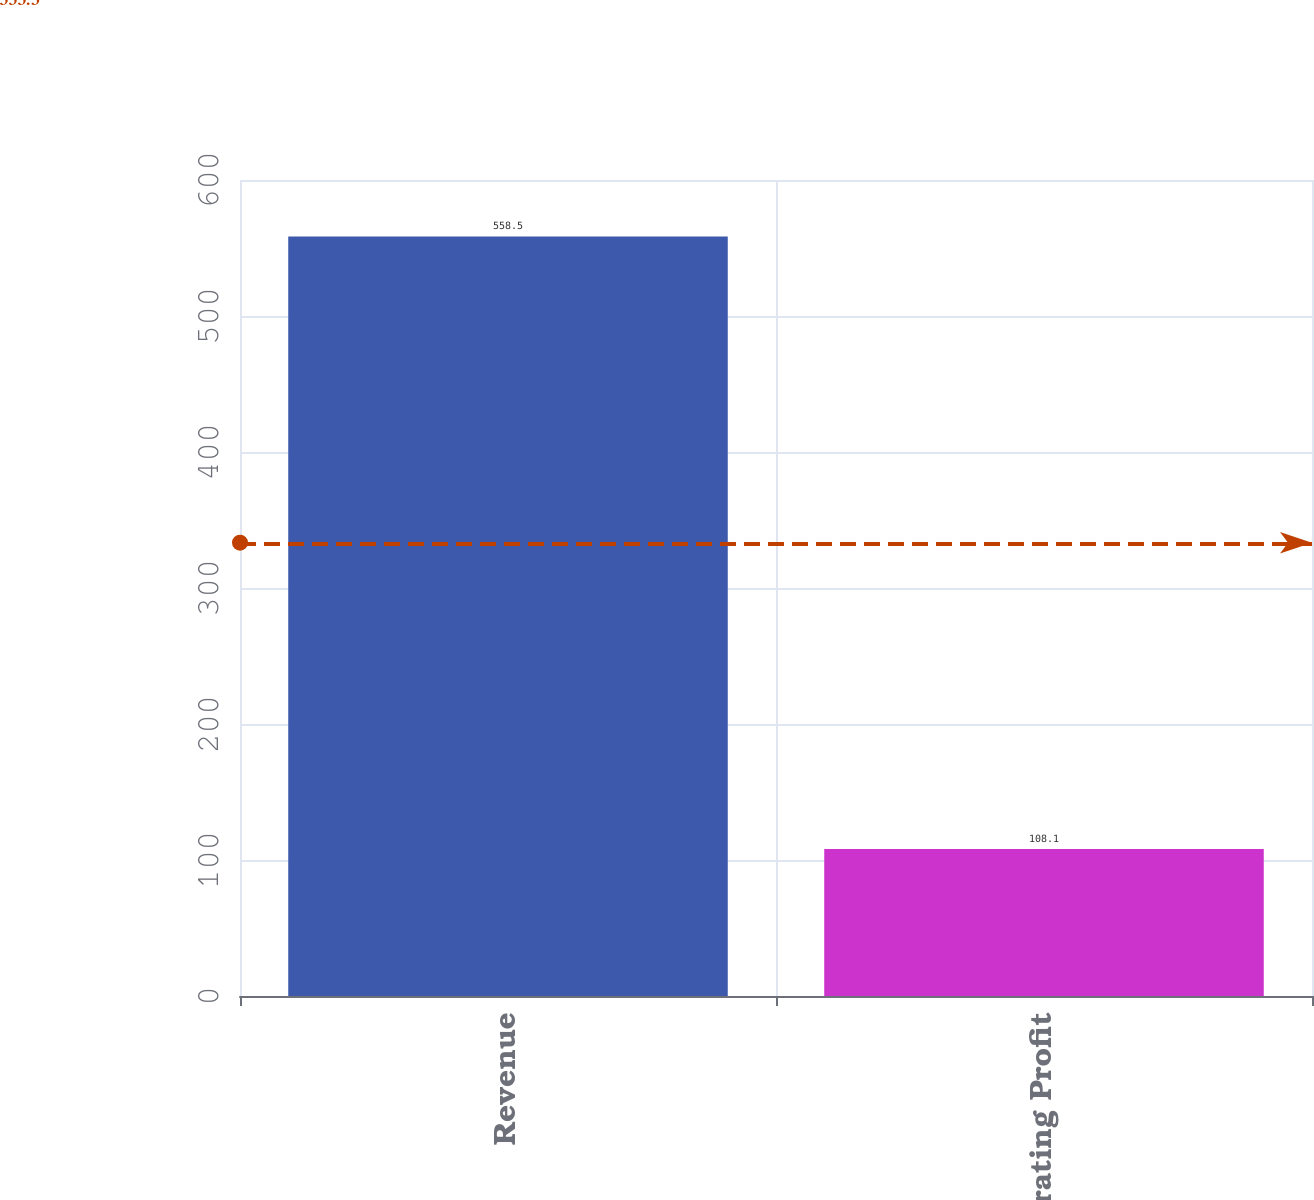<chart> <loc_0><loc_0><loc_500><loc_500><bar_chart><fcel>Revenue<fcel>Operating Profit<nl><fcel>558.5<fcel>108.1<nl></chart> 